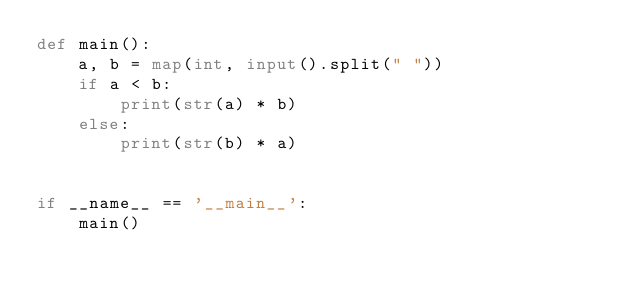Convert code to text. <code><loc_0><loc_0><loc_500><loc_500><_Python_>def main():
    a, b = map(int, input().split(" "))
    if a < b:
        print(str(a) * b)
    else:
        print(str(b) * a)


if __name__ == '__main__':
    main()</code> 